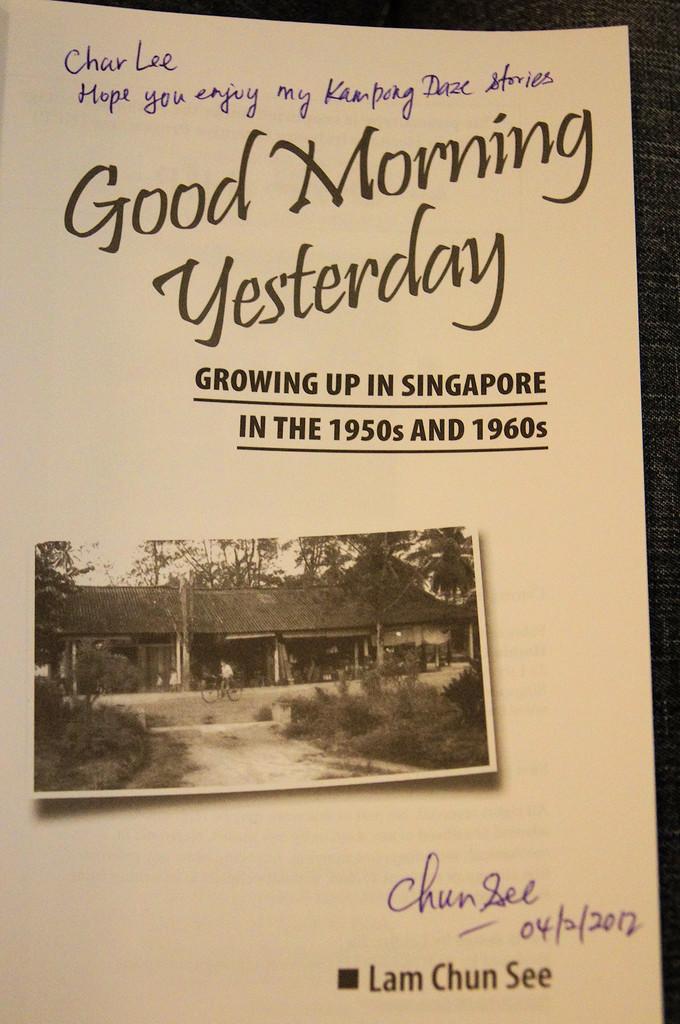What is the title of the book?
Give a very brief answer. Good morning yesterday. 